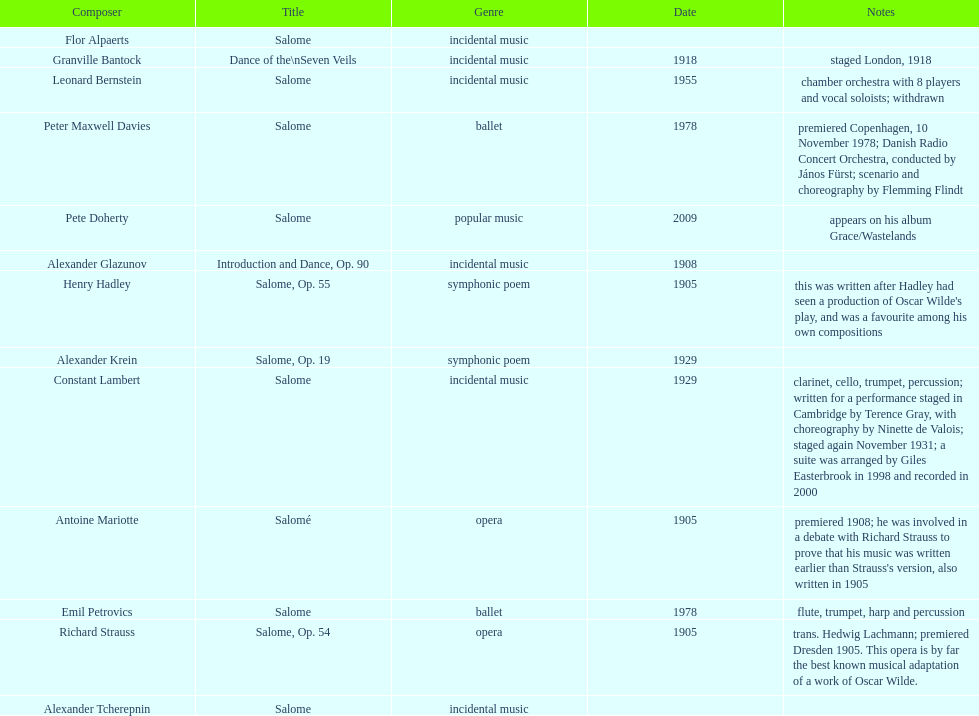Which composer is listed below pete doherty? Alexander Glazunov. 